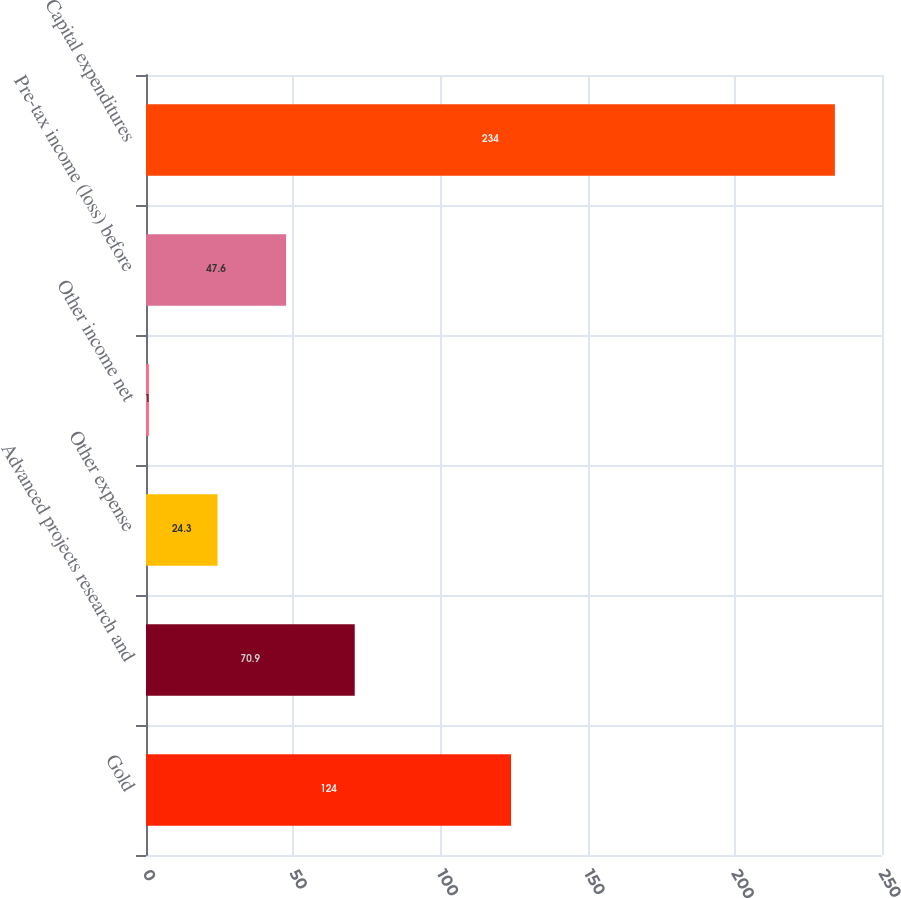Convert chart. <chart><loc_0><loc_0><loc_500><loc_500><bar_chart><fcel>Gold<fcel>Advanced projects research and<fcel>Other expense<fcel>Other income net<fcel>Pre-tax income (loss) before<fcel>Capital expenditures<nl><fcel>124<fcel>70.9<fcel>24.3<fcel>1<fcel>47.6<fcel>234<nl></chart> 